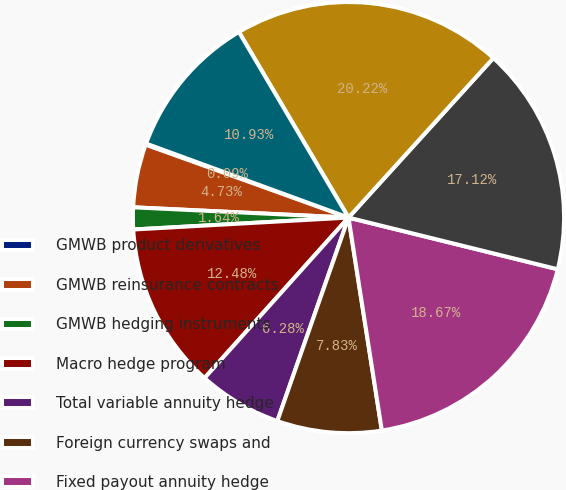<chart> <loc_0><loc_0><loc_500><loc_500><pie_chart><fcel>GMWB product derivatives<fcel>GMWB reinsurance contracts<fcel>GMWB hedging instruments<fcel>Macro hedge program<fcel>Total variable annuity hedge<fcel>Foreign currency swaps and<fcel>Fixed payout annuity hedge<fcel>Total foreign exchange<fcel>Interest rate swaps swaptions<fcel>Credit derivatives that<nl><fcel>0.09%<fcel>4.73%<fcel>1.64%<fcel>12.48%<fcel>6.28%<fcel>7.83%<fcel>18.67%<fcel>17.12%<fcel>20.22%<fcel>10.93%<nl></chart> 